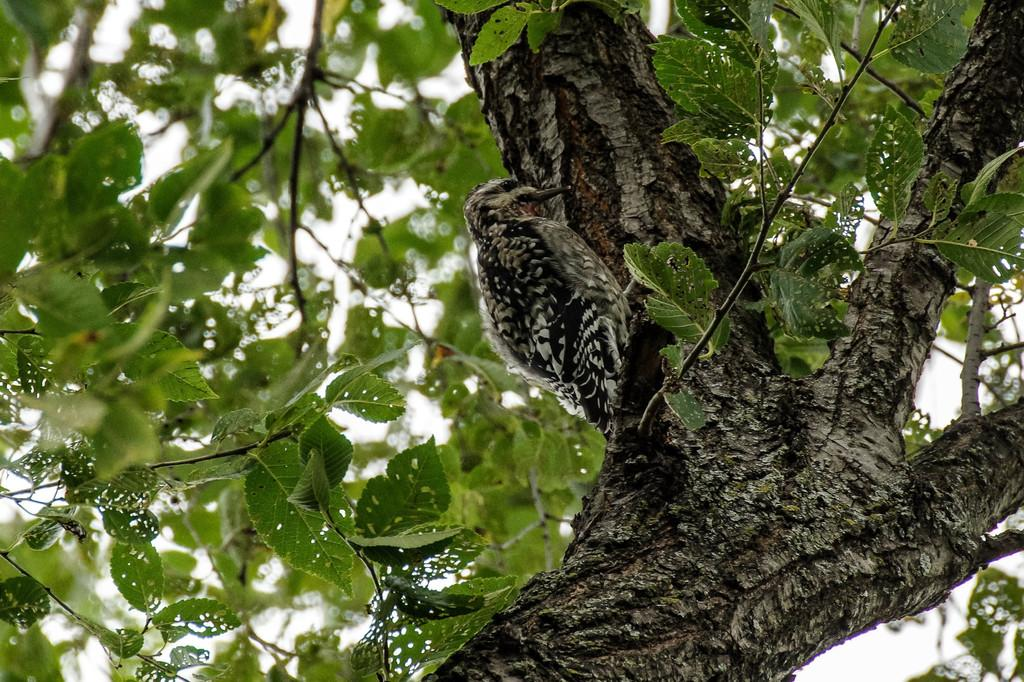What type of animal is present in the image? There is a bird in the image. Where is the bird located? The bird is on the branch of a tree. What part of the natural environment is visible in the image? The sky is visible in the image. Can you hear the bird talking in the image? There is no sound in the image, so it is not possible to determine if the bird is talking. 